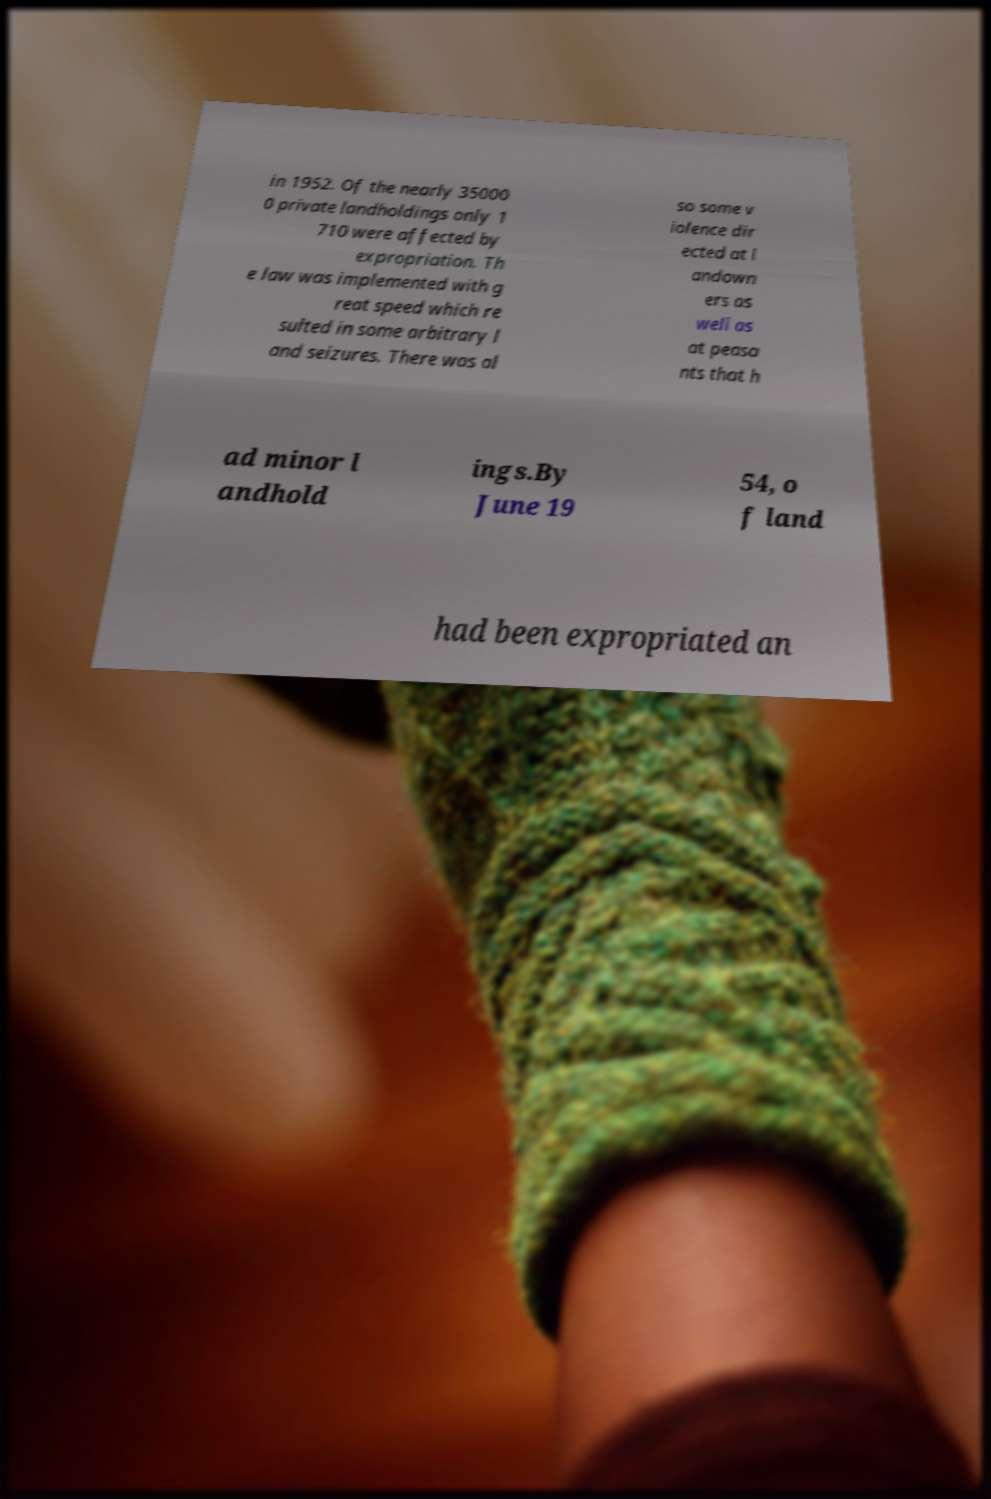Could you assist in decoding the text presented in this image and type it out clearly? in 1952. Of the nearly 35000 0 private landholdings only 1 710 were affected by expropriation. Th e law was implemented with g reat speed which re sulted in some arbitrary l and seizures. There was al so some v iolence dir ected at l andown ers as well as at peasa nts that h ad minor l andhold ings.By June 19 54, o f land had been expropriated an 